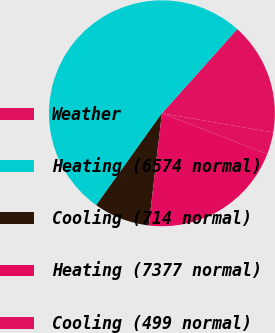Convert chart to OTSL. <chart><loc_0><loc_0><loc_500><loc_500><pie_chart><fcel>Weather<fcel>Heating (6574 normal)<fcel>Cooling (714 normal)<fcel>Heating (7377 normal)<fcel>Cooling (499 normal)<nl><fcel>16.11%<fcel>51.73%<fcel>8.02%<fcel>20.97%<fcel>3.17%<nl></chart> 